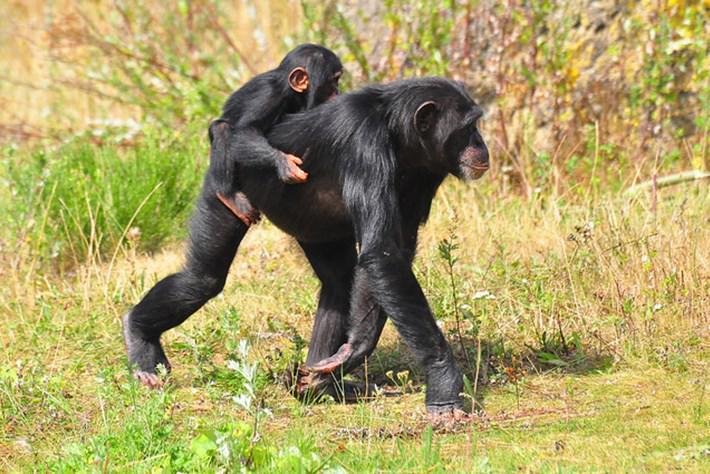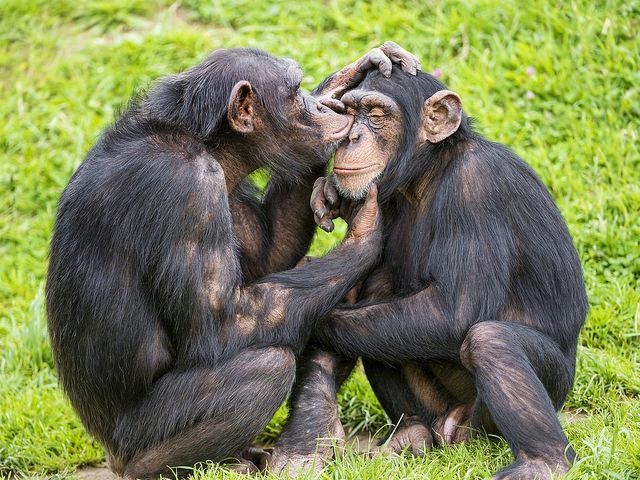The first image is the image on the left, the second image is the image on the right. For the images displayed, is the sentence "An image shows just one baby chimp riding on its mother's back." factually correct? Answer yes or no. Yes. 